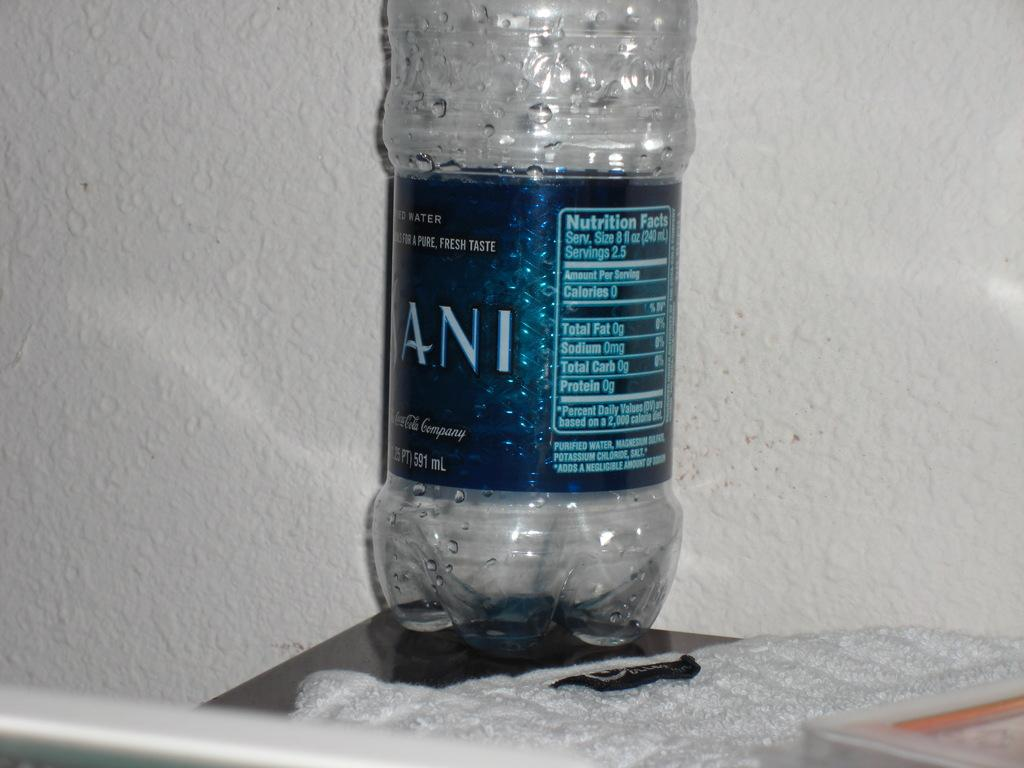<image>
Relay a brief, clear account of the picture shown. An empty Dasani clear plastic water bottle on the corner of a table next to a white wall. 